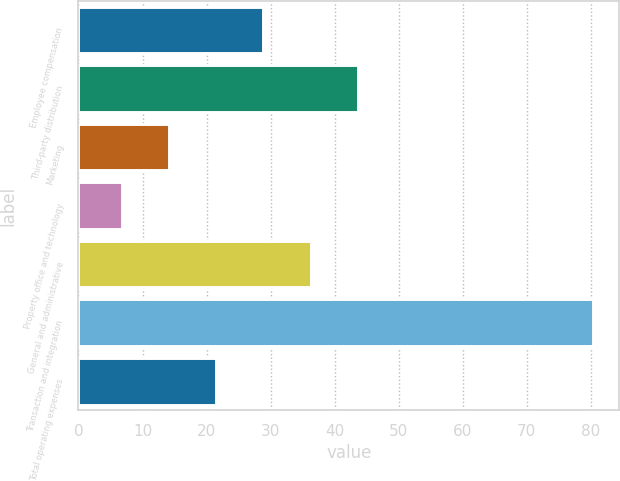Convert chart. <chart><loc_0><loc_0><loc_500><loc_500><bar_chart><fcel>Employee compensation<fcel>Third-party distribution<fcel>Marketing<fcel>Property office and technology<fcel>General and administrative<fcel>Transaction and integration<fcel>Total operating expenses<nl><fcel>28.88<fcel>43.6<fcel>14.16<fcel>6.8<fcel>36.24<fcel>80.4<fcel>21.52<nl></chart> 